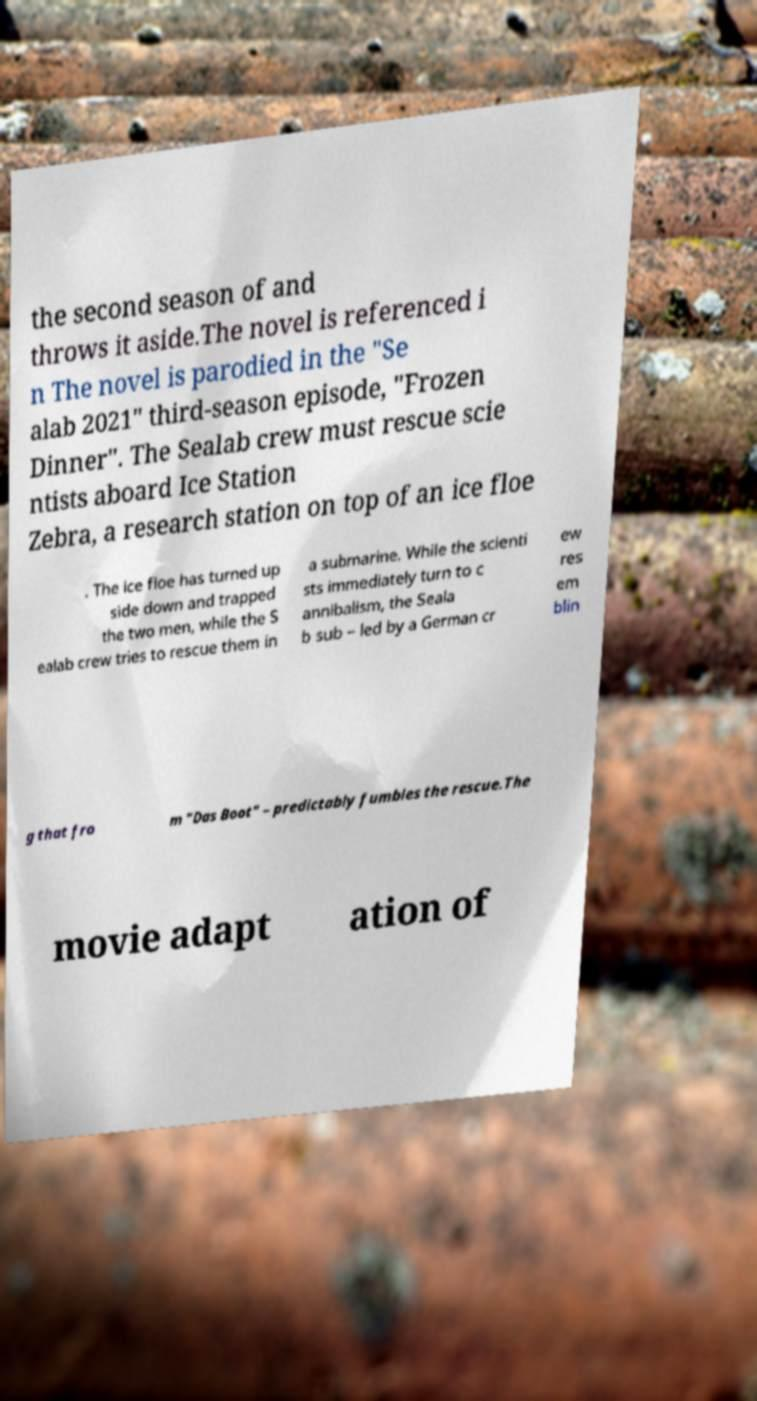Can you accurately transcribe the text from the provided image for me? the second season of and throws it aside.The novel is referenced i n The novel is parodied in the "Se alab 2021" third-season episode, "Frozen Dinner". The Sealab crew must rescue scie ntists aboard Ice Station Zebra, a research station on top of an ice floe . The ice floe has turned up side down and trapped the two men, while the S ealab crew tries to rescue them in a submarine. While the scienti sts immediately turn to c annibalism, the Seala b sub – led by a German cr ew res em blin g that fro m "Das Boot" – predictably fumbles the rescue.The movie adapt ation of 